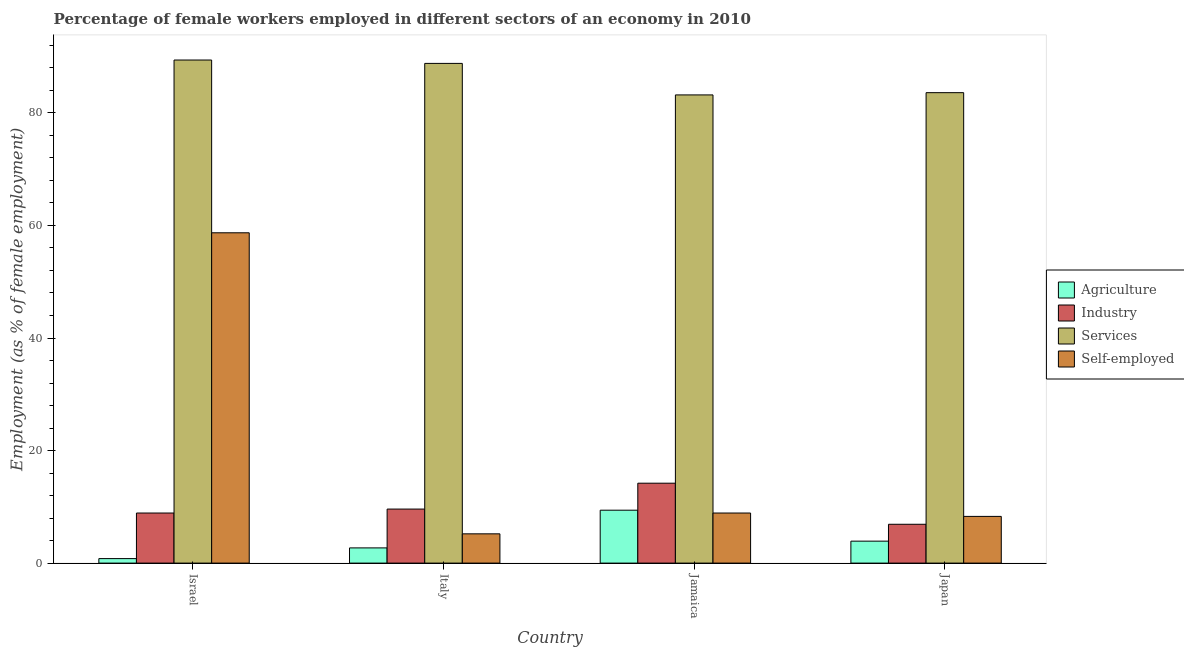How many groups of bars are there?
Offer a very short reply. 4. Are the number of bars per tick equal to the number of legend labels?
Give a very brief answer. Yes. Are the number of bars on each tick of the X-axis equal?
Offer a very short reply. Yes. How many bars are there on the 4th tick from the left?
Provide a succinct answer. 4. How many bars are there on the 3rd tick from the right?
Your response must be concise. 4. In how many cases, is the number of bars for a given country not equal to the number of legend labels?
Your response must be concise. 0. What is the percentage of self employed female workers in Jamaica?
Offer a very short reply. 8.9. Across all countries, what is the maximum percentage of female workers in agriculture?
Make the answer very short. 9.4. Across all countries, what is the minimum percentage of female workers in services?
Provide a succinct answer. 83.2. What is the total percentage of self employed female workers in the graph?
Your response must be concise. 81.1. What is the difference between the percentage of self employed female workers in Italy and that in Jamaica?
Your answer should be compact. -3.7. What is the difference between the percentage of female workers in agriculture in Israel and the percentage of self employed female workers in Jamaica?
Give a very brief answer. -8.1. What is the average percentage of female workers in agriculture per country?
Provide a short and direct response. 4.2. What is the difference between the percentage of female workers in services and percentage of female workers in industry in Jamaica?
Provide a succinct answer. 69. What is the ratio of the percentage of self employed female workers in Israel to that in Italy?
Give a very brief answer. 11.29. Is the percentage of female workers in agriculture in Israel less than that in Jamaica?
Keep it short and to the point. Yes. Is the difference between the percentage of self employed female workers in Israel and Italy greater than the difference between the percentage of female workers in industry in Israel and Italy?
Your response must be concise. Yes. What is the difference between the highest and the second highest percentage of female workers in agriculture?
Give a very brief answer. 5.5. What is the difference between the highest and the lowest percentage of female workers in industry?
Your response must be concise. 7.3. In how many countries, is the percentage of self employed female workers greater than the average percentage of self employed female workers taken over all countries?
Ensure brevity in your answer.  1. What does the 2nd bar from the left in Italy represents?
Offer a very short reply. Industry. What does the 4th bar from the right in Japan represents?
Your response must be concise. Agriculture. Does the graph contain any zero values?
Your answer should be compact. No. Where does the legend appear in the graph?
Make the answer very short. Center right. What is the title of the graph?
Offer a very short reply. Percentage of female workers employed in different sectors of an economy in 2010. What is the label or title of the X-axis?
Make the answer very short. Country. What is the label or title of the Y-axis?
Provide a short and direct response. Employment (as % of female employment). What is the Employment (as % of female employment) of Agriculture in Israel?
Ensure brevity in your answer.  0.8. What is the Employment (as % of female employment) of Industry in Israel?
Your answer should be very brief. 8.9. What is the Employment (as % of female employment) in Services in Israel?
Provide a short and direct response. 89.4. What is the Employment (as % of female employment) of Self-employed in Israel?
Your answer should be very brief. 58.7. What is the Employment (as % of female employment) in Agriculture in Italy?
Provide a succinct answer. 2.7. What is the Employment (as % of female employment) of Industry in Italy?
Provide a short and direct response. 9.6. What is the Employment (as % of female employment) of Services in Italy?
Provide a succinct answer. 88.8. What is the Employment (as % of female employment) of Self-employed in Italy?
Provide a succinct answer. 5.2. What is the Employment (as % of female employment) in Agriculture in Jamaica?
Offer a terse response. 9.4. What is the Employment (as % of female employment) of Industry in Jamaica?
Keep it short and to the point. 14.2. What is the Employment (as % of female employment) of Services in Jamaica?
Make the answer very short. 83.2. What is the Employment (as % of female employment) in Self-employed in Jamaica?
Provide a succinct answer. 8.9. What is the Employment (as % of female employment) of Agriculture in Japan?
Provide a short and direct response. 3.9. What is the Employment (as % of female employment) in Industry in Japan?
Provide a short and direct response. 6.9. What is the Employment (as % of female employment) of Services in Japan?
Your answer should be very brief. 83.6. What is the Employment (as % of female employment) in Self-employed in Japan?
Your response must be concise. 8.3. Across all countries, what is the maximum Employment (as % of female employment) in Agriculture?
Provide a succinct answer. 9.4. Across all countries, what is the maximum Employment (as % of female employment) in Industry?
Keep it short and to the point. 14.2. Across all countries, what is the maximum Employment (as % of female employment) in Services?
Provide a succinct answer. 89.4. Across all countries, what is the maximum Employment (as % of female employment) of Self-employed?
Offer a terse response. 58.7. Across all countries, what is the minimum Employment (as % of female employment) in Agriculture?
Keep it short and to the point. 0.8. Across all countries, what is the minimum Employment (as % of female employment) in Industry?
Offer a very short reply. 6.9. Across all countries, what is the minimum Employment (as % of female employment) in Services?
Provide a short and direct response. 83.2. Across all countries, what is the minimum Employment (as % of female employment) in Self-employed?
Your answer should be very brief. 5.2. What is the total Employment (as % of female employment) in Agriculture in the graph?
Give a very brief answer. 16.8. What is the total Employment (as % of female employment) of Industry in the graph?
Provide a short and direct response. 39.6. What is the total Employment (as % of female employment) in Services in the graph?
Provide a short and direct response. 345. What is the total Employment (as % of female employment) of Self-employed in the graph?
Your answer should be very brief. 81.1. What is the difference between the Employment (as % of female employment) in Agriculture in Israel and that in Italy?
Give a very brief answer. -1.9. What is the difference between the Employment (as % of female employment) in Self-employed in Israel and that in Italy?
Offer a terse response. 53.5. What is the difference between the Employment (as % of female employment) in Industry in Israel and that in Jamaica?
Provide a short and direct response. -5.3. What is the difference between the Employment (as % of female employment) of Self-employed in Israel and that in Jamaica?
Provide a succinct answer. 49.8. What is the difference between the Employment (as % of female employment) in Agriculture in Israel and that in Japan?
Keep it short and to the point. -3.1. What is the difference between the Employment (as % of female employment) of Industry in Israel and that in Japan?
Provide a succinct answer. 2. What is the difference between the Employment (as % of female employment) of Services in Israel and that in Japan?
Provide a short and direct response. 5.8. What is the difference between the Employment (as % of female employment) of Self-employed in Israel and that in Japan?
Offer a very short reply. 50.4. What is the difference between the Employment (as % of female employment) in Agriculture in Italy and that in Jamaica?
Ensure brevity in your answer.  -6.7. What is the difference between the Employment (as % of female employment) in Industry in Italy and that in Jamaica?
Offer a very short reply. -4.6. What is the difference between the Employment (as % of female employment) in Services in Italy and that in Jamaica?
Make the answer very short. 5.6. What is the difference between the Employment (as % of female employment) in Agriculture in Italy and that in Japan?
Make the answer very short. -1.2. What is the difference between the Employment (as % of female employment) in Agriculture in Jamaica and that in Japan?
Your answer should be compact. 5.5. What is the difference between the Employment (as % of female employment) in Industry in Jamaica and that in Japan?
Provide a short and direct response. 7.3. What is the difference between the Employment (as % of female employment) in Services in Jamaica and that in Japan?
Provide a short and direct response. -0.4. What is the difference between the Employment (as % of female employment) of Self-employed in Jamaica and that in Japan?
Make the answer very short. 0.6. What is the difference between the Employment (as % of female employment) of Agriculture in Israel and the Employment (as % of female employment) of Services in Italy?
Provide a short and direct response. -88. What is the difference between the Employment (as % of female employment) in Agriculture in Israel and the Employment (as % of female employment) in Self-employed in Italy?
Give a very brief answer. -4.4. What is the difference between the Employment (as % of female employment) in Industry in Israel and the Employment (as % of female employment) in Services in Italy?
Offer a very short reply. -79.9. What is the difference between the Employment (as % of female employment) in Services in Israel and the Employment (as % of female employment) in Self-employed in Italy?
Provide a succinct answer. 84.2. What is the difference between the Employment (as % of female employment) in Agriculture in Israel and the Employment (as % of female employment) in Industry in Jamaica?
Make the answer very short. -13.4. What is the difference between the Employment (as % of female employment) of Agriculture in Israel and the Employment (as % of female employment) of Services in Jamaica?
Make the answer very short. -82.4. What is the difference between the Employment (as % of female employment) of Industry in Israel and the Employment (as % of female employment) of Services in Jamaica?
Make the answer very short. -74.3. What is the difference between the Employment (as % of female employment) of Services in Israel and the Employment (as % of female employment) of Self-employed in Jamaica?
Offer a very short reply. 80.5. What is the difference between the Employment (as % of female employment) of Agriculture in Israel and the Employment (as % of female employment) of Services in Japan?
Keep it short and to the point. -82.8. What is the difference between the Employment (as % of female employment) of Agriculture in Israel and the Employment (as % of female employment) of Self-employed in Japan?
Provide a succinct answer. -7.5. What is the difference between the Employment (as % of female employment) of Industry in Israel and the Employment (as % of female employment) of Services in Japan?
Your answer should be very brief. -74.7. What is the difference between the Employment (as % of female employment) in Industry in Israel and the Employment (as % of female employment) in Self-employed in Japan?
Offer a very short reply. 0.6. What is the difference between the Employment (as % of female employment) in Services in Israel and the Employment (as % of female employment) in Self-employed in Japan?
Provide a short and direct response. 81.1. What is the difference between the Employment (as % of female employment) of Agriculture in Italy and the Employment (as % of female employment) of Services in Jamaica?
Provide a short and direct response. -80.5. What is the difference between the Employment (as % of female employment) in Industry in Italy and the Employment (as % of female employment) in Services in Jamaica?
Your answer should be very brief. -73.6. What is the difference between the Employment (as % of female employment) of Industry in Italy and the Employment (as % of female employment) of Self-employed in Jamaica?
Offer a terse response. 0.7. What is the difference between the Employment (as % of female employment) in Services in Italy and the Employment (as % of female employment) in Self-employed in Jamaica?
Make the answer very short. 79.9. What is the difference between the Employment (as % of female employment) of Agriculture in Italy and the Employment (as % of female employment) of Services in Japan?
Provide a succinct answer. -80.9. What is the difference between the Employment (as % of female employment) in Agriculture in Italy and the Employment (as % of female employment) in Self-employed in Japan?
Your answer should be very brief. -5.6. What is the difference between the Employment (as % of female employment) in Industry in Italy and the Employment (as % of female employment) in Services in Japan?
Make the answer very short. -74. What is the difference between the Employment (as % of female employment) of Services in Italy and the Employment (as % of female employment) of Self-employed in Japan?
Offer a very short reply. 80.5. What is the difference between the Employment (as % of female employment) of Agriculture in Jamaica and the Employment (as % of female employment) of Industry in Japan?
Provide a succinct answer. 2.5. What is the difference between the Employment (as % of female employment) of Agriculture in Jamaica and the Employment (as % of female employment) of Services in Japan?
Give a very brief answer. -74.2. What is the difference between the Employment (as % of female employment) of Agriculture in Jamaica and the Employment (as % of female employment) of Self-employed in Japan?
Give a very brief answer. 1.1. What is the difference between the Employment (as % of female employment) in Industry in Jamaica and the Employment (as % of female employment) in Services in Japan?
Ensure brevity in your answer.  -69.4. What is the difference between the Employment (as % of female employment) of Industry in Jamaica and the Employment (as % of female employment) of Self-employed in Japan?
Provide a short and direct response. 5.9. What is the difference between the Employment (as % of female employment) in Services in Jamaica and the Employment (as % of female employment) in Self-employed in Japan?
Your answer should be compact. 74.9. What is the average Employment (as % of female employment) in Agriculture per country?
Keep it short and to the point. 4.2. What is the average Employment (as % of female employment) of Services per country?
Ensure brevity in your answer.  86.25. What is the average Employment (as % of female employment) in Self-employed per country?
Provide a short and direct response. 20.27. What is the difference between the Employment (as % of female employment) in Agriculture and Employment (as % of female employment) in Services in Israel?
Provide a succinct answer. -88.6. What is the difference between the Employment (as % of female employment) of Agriculture and Employment (as % of female employment) of Self-employed in Israel?
Provide a short and direct response. -57.9. What is the difference between the Employment (as % of female employment) in Industry and Employment (as % of female employment) in Services in Israel?
Give a very brief answer. -80.5. What is the difference between the Employment (as % of female employment) of Industry and Employment (as % of female employment) of Self-employed in Israel?
Provide a succinct answer. -49.8. What is the difference between the Employment (as % of female employment) in Services and Employment (as % of female employment) in Self-employed in Israel?
Give a very brief answer. 30.7. What is the difference between the Employment (as % of female employment) of Agriculture and Employment (as % of female employment) of Services in Italy?
Your response must be concise. -86.1. What is the difference between the Employment (as % of female employment) in Agriculture and Employment (as % of female employment) in Self-employed in Italy?
Keep it short and to the point. -2.5. What is the difference between the Employment (as % of female employment) in Industry and Employment (as % of female employment) in Services in Italy?
Provide a short and direct response. -79.2. What is the difference between the Employment (as % of female employment) of Services and Employment (as % of female employment) of Self-employed in Italy?
Offer a very short reply. 83.6. What is the difference between the Employment (as % of female employment) in Agriculture and Employment (as % of female employment) in Industry in Jamaica?
Make the answer very short. -4.8. What is the difference between the Employment (as % of female employment) in Agriculture and Employment (as % of female employment) in Services in Jamaica?
Offer a very short reply. -73.8. What is the difference between the Employment (as % of female employment) in Agriculture and Employment (as % of female employment) in Self-employed in Jamaica?
Your response must be concise. 0.5. What is the difference between the Employment (as % of female employment) in Industry and Employment (as % of female employment) in Services in Jamaica?
Your answer should be very brief. -69. What is the difference between the Employment (as % of female employment) of Industry and Employment (as % of female employment) of Self-employed in Jamaica?
Your response must be concise. 5.3. What is the difference between the Employment (as % of female employment) in Services and Employment (as % of female employment) in Self-employed in Jamaica?
Your answer should be very brief. 74.3. What is the difference between the Employment (as % of female employment) in Agriculture and Employment (as % of female employment) in Industry in Japan?
Your answer should be compact. -3. What is the difference between the Employment (as % of female employment) of Agriculture and Employment (as % of female employment) of Services in Japan?
Ensure brevity in your answer.  -79.7. What is the difference between the Employment (as % of female employment) in Agriculture and Employment (as % of female employment) in Self-employed in Japan?
Provide a short and direct response. -4.4. What is the difference between the Employment (as % of female employment) in Industry and Employment (as % of female employment) in Services in Japan?
Offer a very short reply. -76.7. What is the difference between the Employment (as % of female employment) of Industry and Employment (as % of female employment) of Self-employed in Japan?
Your response must be concise. -1.4. What is the difference between the Employment (as % of female employment) in Services and Employment (as % of female employment) in Self-employed in Japan?
Your response must be concise. 75.3. What is the ratio of the Employment (as % of female employment) in Agriculture in Israel to that in Italy?
Make the answer very short. 0.3. What is the ratio of the Employment (as % of female employment) in Industry in Israel to that in Italy?
Your answer should be very brief. 0.93. What is the ratio of the Employment (as % of female employment) of Services in Israel to that in Italy?
Ensure brevity in your answer.  1.01. What is the ratio of the Employment (as % of female employment) of Self-employed in Israel to that in Italy?
Your answer should be very brief. 11.29. What is the ratio of the Employment (as % of female employment) of Agriculture in Israel to that in Jamaica?
Offer a very short reply. 0.09. What is the ratio of the Employment (as % of female employment) of Industry in Israel to that in Jamaica?
Your response must be concise. 0.63. What is the ratio of the Employment (as % of female employment) of Services in Israel to that in Jamaica?
Give a very brief answer. 1.07. What is the ratio of the Employment (as % of female employment) in Self-employed in Israel to that in Jamaica?
Provide a succinct answer. 6.6. What is the ratio of the Employment (as % of female employment) of Agriculture in Israel to that in Japan?
Your answer should be very brief. 0.21. What is the ratio of the Employment (as % of female employment) in Industry in Israel to that in Japan?
Offer a very short reply. 1.29. What is the ratio of the Employment (as % of female employment) in Services in Israel to that in Japan?
Offer a terse response. 1.07. What is the ratio of the Employment (as % of female employment) in Self-employed in Israel to that in Japan?
Keep it short and to the point. 7.07. What is the ratio of the Employment (as % of female employment) in Agriculture in Italy to that in Jamaica?
Keep it short and to the point. 0.29. What is the ratio of the Employment (as % of female employment) of Industry in Italy to that in Jamaica?
Provide a short and direct response. 0.68. What is the ratio of the Employment (as % of female employment) of Services in Italy to that in Jamaica?
Offer a terse response. 1.07. What is the ratio of the Employment (as % of female employment) in Self-employed in Italy to that in Jamaica?
Provide a short and direct response. 0.58. What is the ratio of the Employment (as % of female employment) of Agriculture in Italy to that in Japan?
Your answer should be compact. 0.69. What is the ratio of the Employment (as % of female employment) in Industry in Italy to that in Japan?
Your answer should be compact. 1.39. What is the ratio of the Employment (as % of female employment) in Services in Italy to that in Japan?
Offer a very short reply. 1.06. What is the ratio of the Employment (as % of female employment) of Self-employed in Italy to that in Japan?
Your answer should be very brief. 0.63. What is the ratio of the Employment (as % of female employment) of Agriculture in Jamaica to that in Japan?
Make the answer very short. 2.41. What is the ratio of the Employment (as % of female employment) of Industry in Jamaica to that in Japan?
Your answer should be very brief. 2.06. What is the ratio of the Employment (as % of female employment) of Self-employed in Jamaica to that in Japan?
Give a very brief answer. 1.07. What is the difference between the highest and the second highest Employment (as % of female employment) of Agriculture?
Provide a succinct answer. 5.5. What is the difference between the highest and the second highest Employment (as % of female employment) in Industry?
Ensure brevity in your answer.  4.6. What is the difference between the highest and the second highest Employment (as % of female employment) of Services?
Ensure brevity in your answer.  0.6. What is the difference between the highest and the second highest Employment (as % of female employment) of Self-employed?
Your response must be concise. 49.8. What is the difference between the highest and the lowest Employment (as % of female employment) in Self-employed?
Ensure brevity in your answer.  53.5. 